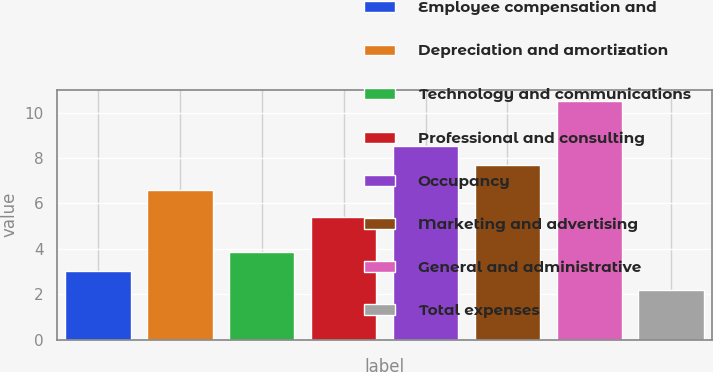Convert chart. <chart><loc_0><loc_0><loc_500><loc_500><bar_chart><fcel>Employee compensation and<fcel>Depreciation and amortization<fcel>Technology and communications<fcel>Professional and consulting<fcel>Occupancy<fcel>Marketing and advertising<fcel>General and administrative<fcel>Total expenses<nl><fcel>3.03<fcel>6.6<fcel>3.86<fcel>5.4<fcel>8.53<fcel>7.7<fcel>10.5<fcel>2.2<nl></chart> 